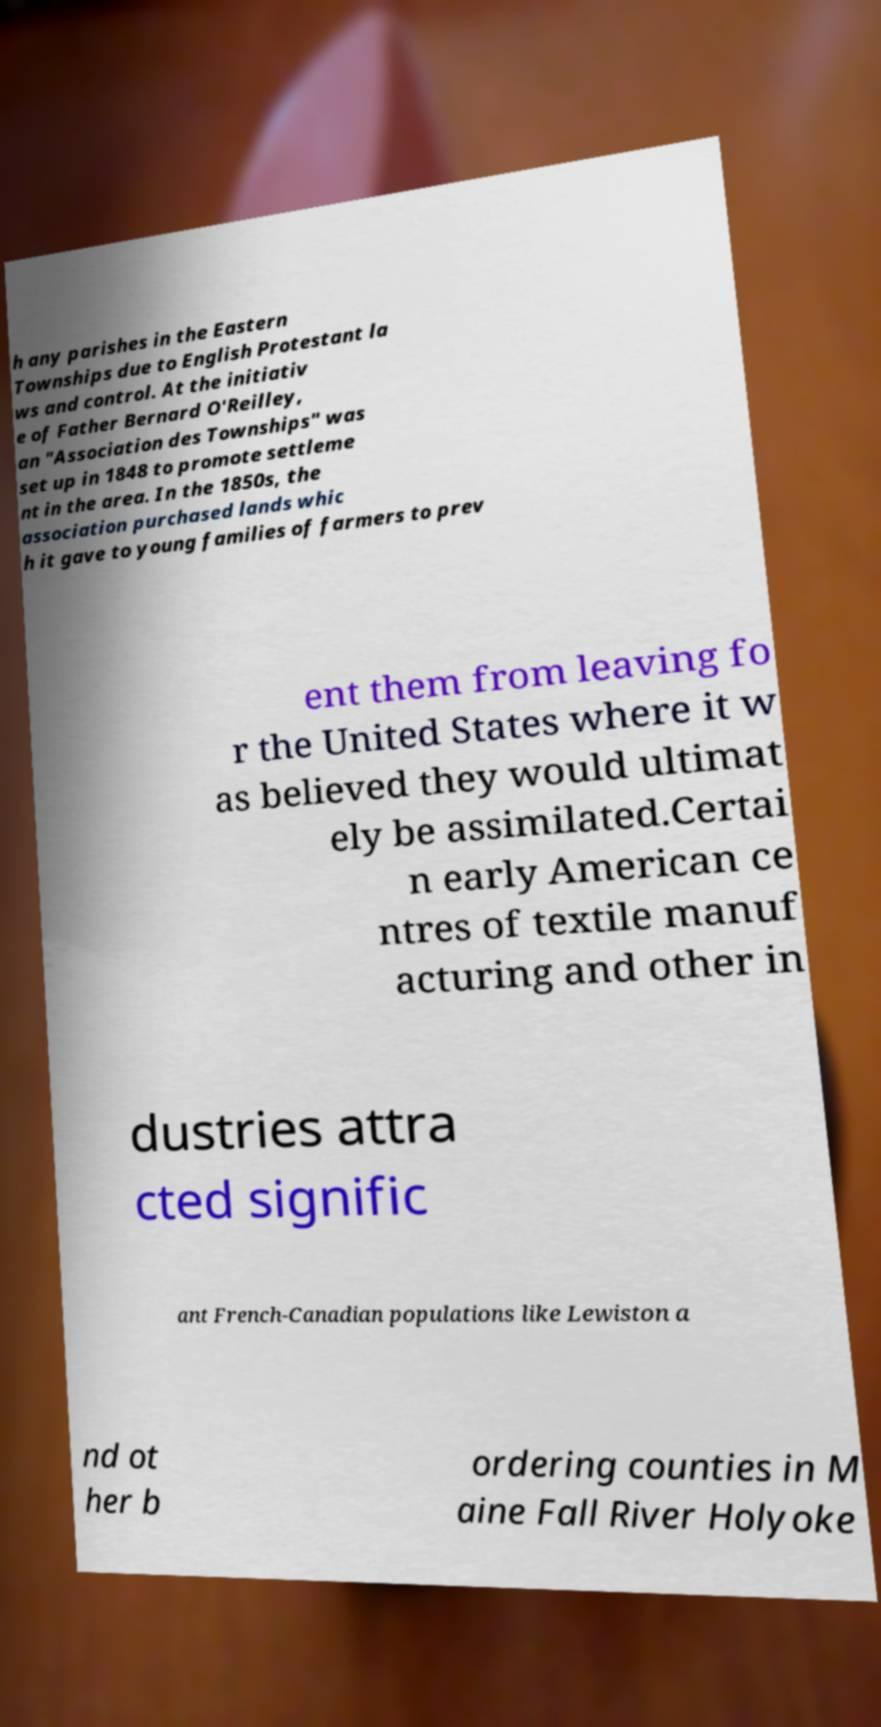Can you read and provide the text displayed in the image?This photo seems to have some interesting text. Can you extract and type it out for me? h any parishes in the Eastern Townships due to English Protestant la ws and control. At the initiativ e of Father Bernard O'Reilley, an "Association des Townships" was set up in 1848 to promote settleme nt in the area. In the 1850s, the association purchased lands whic h it gave to young families of farmers to prev ent them from leaving fo r the United States where it w as believed they would ultimat ely be assimilated.Certai n early American ce ntres of textile manuf acturing and other in dustries attra cted signific ant French-Canadian populations like Lewiston a nd ot her b ordering counties in M aine Fall River Holyoke 